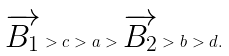Convert formula to latex. <formula><loc_0><loc_0><loc_500><loc_500>\overrightarrow { B _ { 1 } } > c > a > \overrightarrow { B _ { 2 } } > b > d .</formula> 